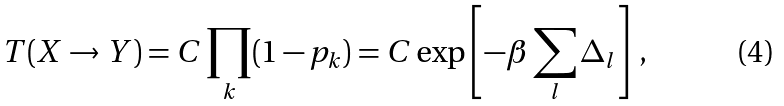<formula> <loc_0><loc_0><loc_500><loc_500>T ( X \to Y ) = C \prod _ { k } ( 1 - p _ { k } ) = C \exp \left [ - \beta \sum _ { l } \Delta _ { l } \right ] \, ,</formula> 